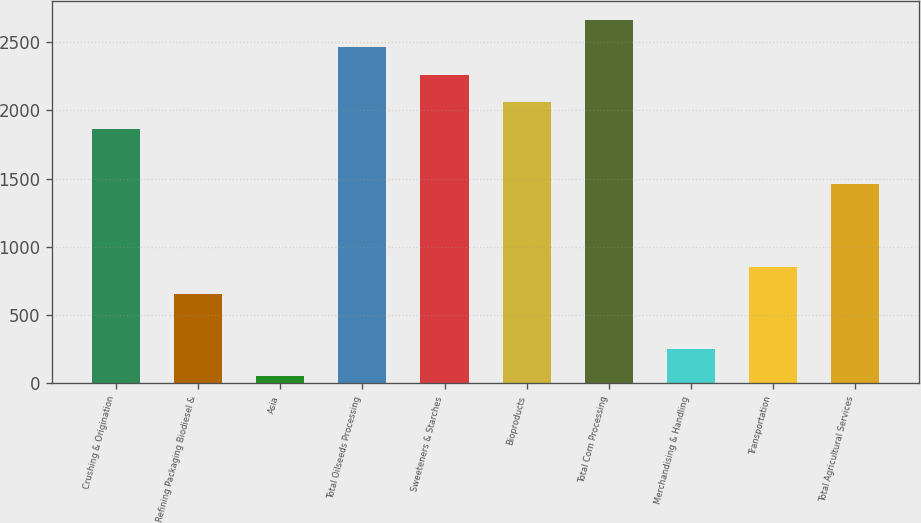Convert chart to OTSL. <chart><loc_0><loc_0><loc_500><loc_500><bar_chart><fcel>Crushing & Origination<fcel>Refining Packaging Biodiesel &<fcel>Asia<fcel>Total Oilseeds Processing<fcel>Sweeteners & Starches<fcel>Bioproducts<fcel>Total Corn Processing<fcel>Merchandising & Handling<fcel>Transportation<fcel>Total Agricultural Services<nl><fcel>1860.2<fcel>655.4<fcel>53<fcel>2462.6<fcel>2261.8<fcel>2061<fcel>2663.4<fcel>253.8<fcel>856.2<fcel>1458.6<nl></chart> 